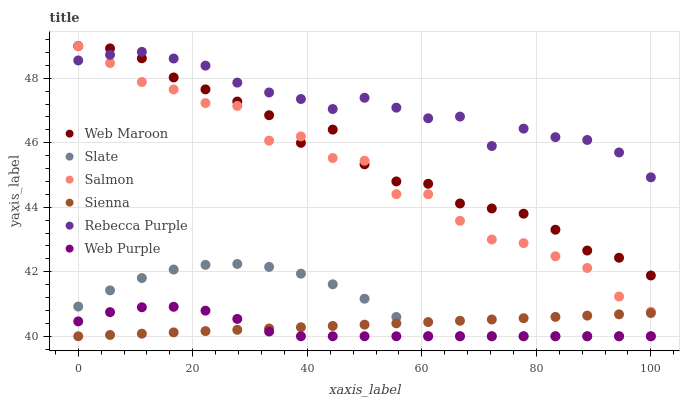Does Web Purple have the minimum area under the curve?
Answer yes or no. Yes. Does Rebecca Purple have the maximum area under the curve?
Answer yes or no. Yes. Does Slate have the minimum area under the curve?
Answer yes or no. No. Does Slate have the maximum area under the curve?
Answer yes or no. No. Is Sienna the smoothest?
Answer yes or no. Yes. Is Salmon the roughest?
Answer yes or no. Yes. Is Slate the smoothest?
Answer yes or no. No. Is Slate the roughest?
Answer yes or no. No. Does Slate have the lowest value?
Answer yes or no. Yes. Does Salmon have the lowest value?
Answer yes or no. No. Does Salmon have the highest value?
Answer yes or no. Yes. Does Slate have the highest value?
Answer yes or no. No. Is Sienna less than Rebecca Purple?
Answer yes or no. Yes. Is Salmon greater than Sienna?
Answer yes or no. Yes. Does Web Maroon intersect Salmon?
Answer yes or no. Yes. Is Web Maroon less than Salmon?
Answer yes or no. No. Is Web Maroon greater than Salmon?
Answer yes or no. No. Does Sienna intersect Rebecca Purple?
Answer yes or no. No. 